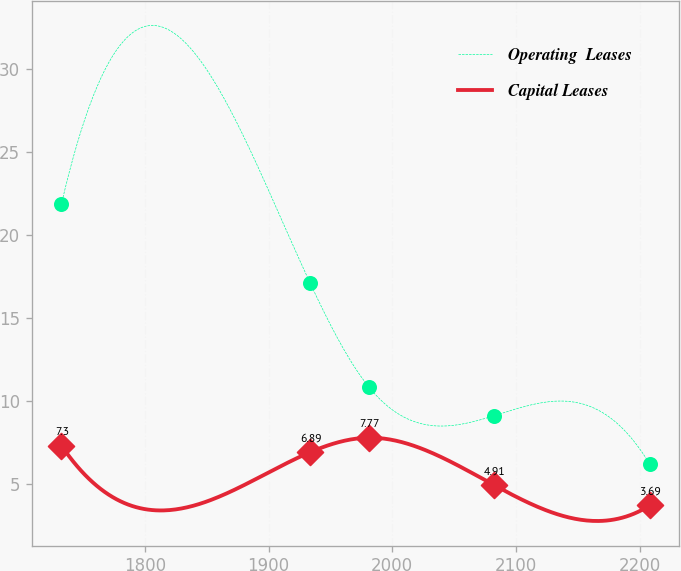Convert chart. <chart><loc_0><loc_0><loc_500><loc_500><line_chart><ecel><fcel>Operating  Leases<fcel>Capital Leases<nl><fcel>1732.51<fcel>21.83<fcel>7.3<nl><fcel>1933.44<fcel>17.12<fcel>6.89<nl><fcel>1981.01<fcel>10.84<fcel>7.77<nl><fcel>2082.55<fcel>9.1<fcel>4.91<nl><fcel>2208.25<fcel>6.18<fcel>3.69<nl></chart> 